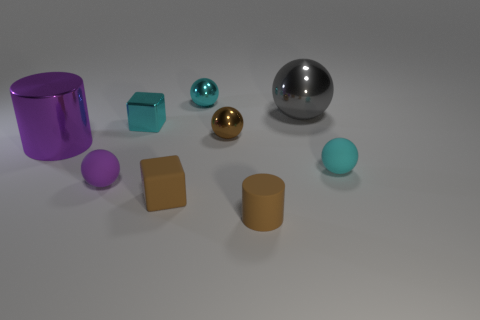Subtract 1 spheres. How many spheres are left? 4 Subtract all gray spheres. How many spheres are left? 4 Subtract all gray metallic spheres. How many spheres are left? 4 Subtract all red balls. Subtract all yellow cubes. How many balls are left? 5 Subtract all blocks. How many objects are left? 7 Subtract all large gray shiny spheres. Subtract all tiny cyan metallic objects. How many objects are left? 6 Add 4 purple cylinders. How many purple cylinders are left? 5 Add 7 big yellow metal balls. How many big yellow metal balls exist? 7 Subtract 0 red cubes. How many objects are left? 9 